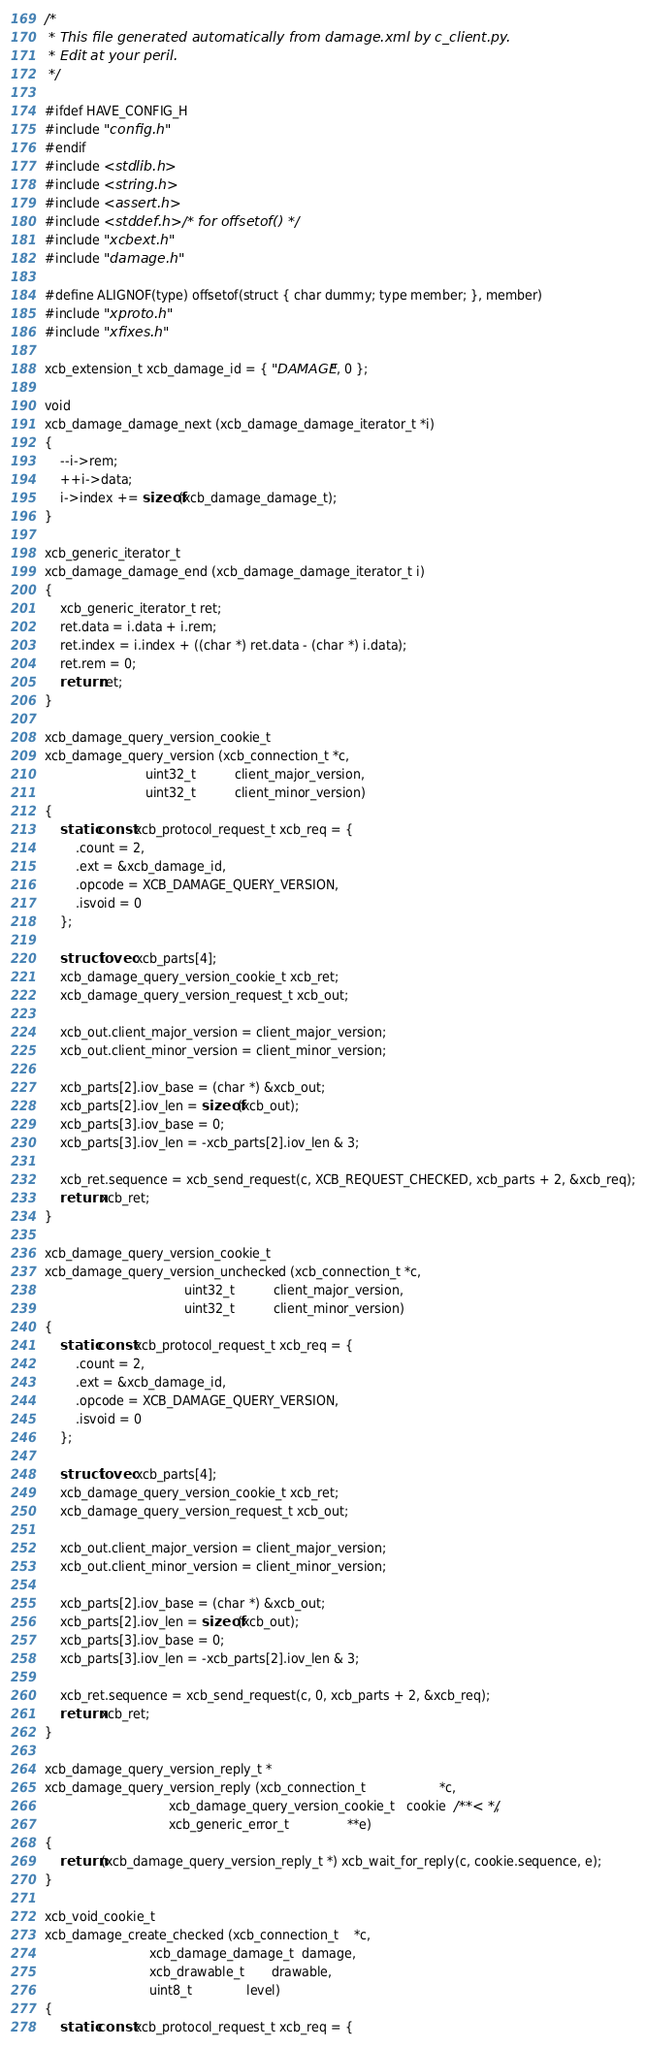<code> <loc_0><loc_0><loc_500><loc_500><_C_>/*
 * This file generated automatically from damage.xml by c_client.py.
 * Edit at your peril.
 */

#ifdef HAVE_CONFIG_H
#include "config.h"
#endif
#include <stdlib.h>
#include <string.h>
#include <assert.h>
#include <stddef.h>  /* for offsetof() */
#include "xcbext.h"
#include "damage.h"

#define ALIGNOF(type) offsetof(struct { char dummy; type member; }, member)
#include "xproto.h"
#include "xfixes.h"

xcb_extension_t xcb_damage_id = { "DAMAGE", 0 };

void
xcb_damage_damage_next (xcb_damage_damage_iterator_t *i)
{
    --i->rem;
    ++i->data;
    i->index += sizeof(xcb_damage_damage_t);
}

xcb_generic_iterator_t
xcb_damage_damage_end (xcb_damage_damage_iterator_t i)
{
    xcb_generic_iterator_t ret;
    ret.data = i.data + i.rem;
    ret.index = i.index + ((char *) ret.data - (char *) i.data);
    ret.rem = 0;
    return ret;
}

xcb_damage_query_version_cookie_t
xcb_damage_query_version (xcb_connection_t *c,
                          uint32_t          client_major_version,
                          uint32_t          client_minor_version)
{
    static const xcb_protocol_request_t xcb_req = {
        .count = 2,
        .ext = &xcb_damage_id,
        .opcode = XCB_DAMAGE_QUERY_VERSION,
        .isvoid = 0
    };

    struct iovec xcb_parts[4];
    xcb_damage_query_version_cookie_t xcb_ret;
    xcb_damage_query_version_request_t xcb_out;

    xcb_out.client_major_version = client_major_version;
    xcb_out.client_minor_version = client_minor_version;

    xcb_parts[2].iov_base = (char *) &xcb_out;
    xcb_parts[2].iov_len = sizeof(xcb_out);
    xcb_parts[3].iov_base = 0;
    xcb_parts[3].iov_len = -xcb_parts[2].iov_len & 3;

    xcb_ret.sequence = xcb_send_request(c, XCB_REQUEST_CHECKED, xcb_parts + 2, &xcb_req);
    return xcb_ret;
}

xcb_damage_query_version_cookie_t
xcb_damage_query_version_unchecked (xcb_connection_t *c,
                                    uint32_t          client_major_version,
                                    uint32_t          client_minor_version)
{
    static const xcb_protocol_request_t xcb_req = {
        .count = 2,
        .ext = &xcb_damage_id,
        .opcode = XCB_DAMAGE_QUERY_VERSION,
        .isvoid = 0
    };

    struct iovec xcb_parts[4];
    xcb_damage_query_version_cookie_t xcb_ret;
    xcb_damage_query_version_request_t xcb_out;

    xcb_out.client_major_version = client_major_version;
    xcb_out.client_minor_version = client_minor_version;

    xcb_parts[2].iov_base = (char *) &xcb_out;
    xcb_parts[2].iov_len = sizeof(xcb_out);
    xcb_parts[3].iov_base = 0;
    xcb_parts[3].iov_len = -xcb_parts[2].iov_len & 3;

    xcb_ret.sequence = xcb_send_request(c, 0, xcb_parts + 2, &xcb_req);
    return xcb_ret;
}

xcb_damage_query_version_reply_t *
xcb_damage_query_version_reply (xcb_connection_t                   *c,
                                xcb_damage_query_version_cookie_t   cookie  /**< */,
                                xcb_generic_error_t               **e)
{
    return (xcb_damage_query_version_reply_t *) xcb_wait_for_reply(c, cookie.sequence, e);
}

xcb_void_cookie_t
xcb_damage_create_checked (xcb_connection_t    *c,
                           xcb_damage_damage_t  damage,
                           xcb_drawable_t       drawable,
                           uint8_t              level)
{
    static const xcb_protocol_request_t xcb_req = {</code> 